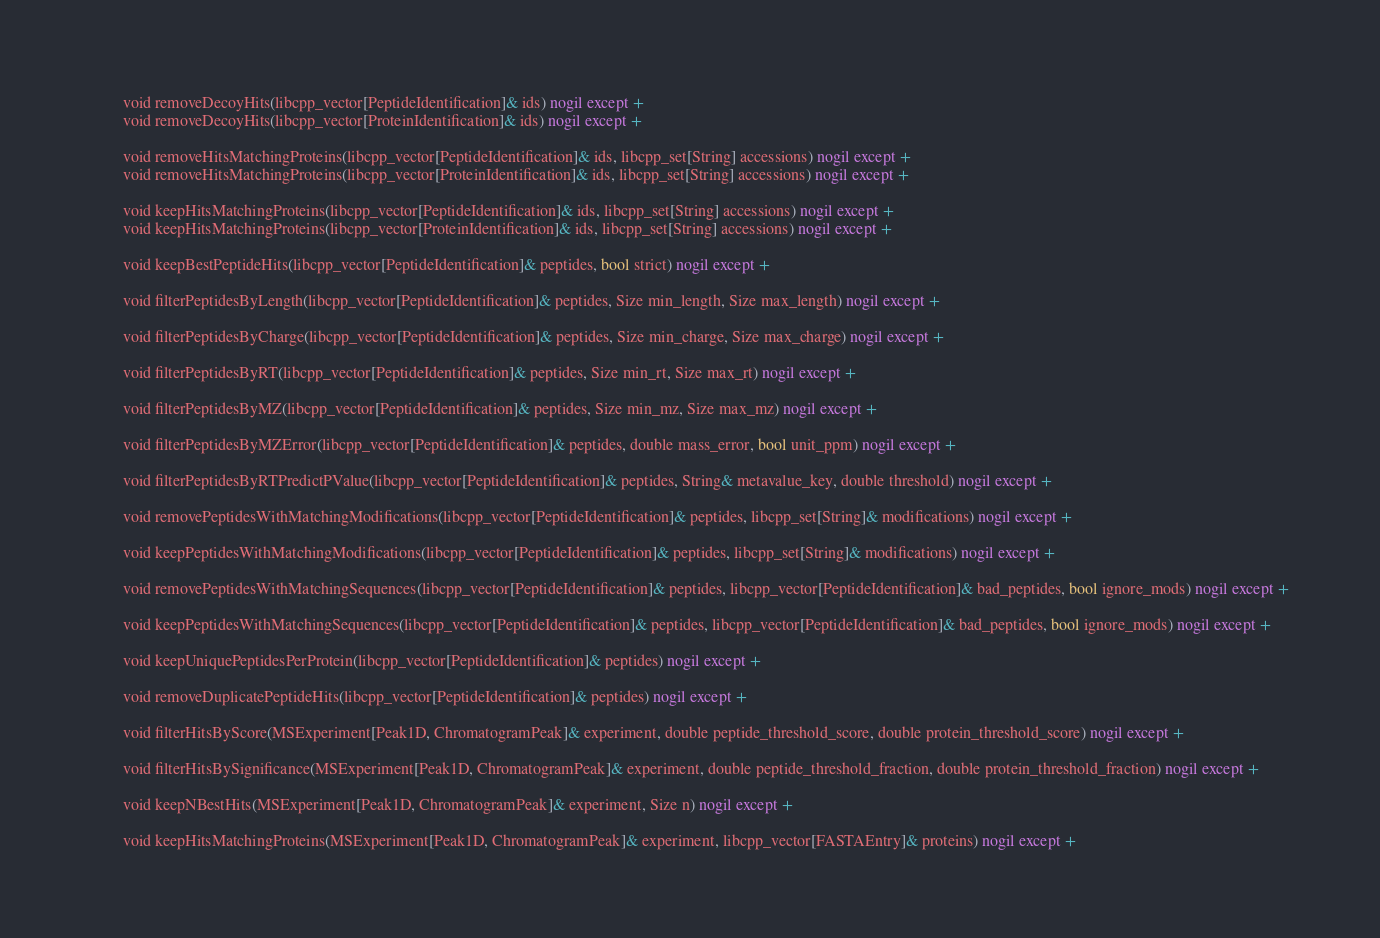<code> <loc_0><loc_0><loc_500><loc_500><_Cython_>        void removeDecoyHits(libcpp_vector[PeptideIdentification]& ids) nogil except +
        void removeDecoyHits(libcpp_vector[ProteinIdentification]& ids) nogil except +

        void removeHitsMatchingProteins(libcpp_vector[PeptideIdentification]& ids, libcpp_set[String] accessions) nogil except +
        void removeHitsMatchingProteins(libcpp_vector[ProteinIdentification]& ids, libcpp_set[String] accessions) nogil except +

        void keepHitsMatchingProteins(libcpp_vector[PeptideIdentification]& ids, libcpp_set[String] accessions) nogil except +
        void keepHitsMatchingProteins(libcpp_vector[ProteinIdentification]& ids, libcpp_set[String] accessions) nogil except +

        void keepBestPeptideHits(libcpp_vector[PeptideIdentification]& peptides, bool strict) nogil except +

        void filterPeptidesByLength(libcpp_vector[PeptideIdentification]& peptides, Size min_length, Size max_length) nogil except +

        void filterPeptidesByCharge(libcpp_vector[PeptideIdentification]& peptides, Size min_charge, Size max_charge) nogil except +

        void filterPeptidesByRT(libcpp_vector[PeptideIdentification]& peptides, Size min_rt, Size max_rt) nogil except +

        void filterPeptidesByMZ(libcpp_vector[PeptideIdentification]& peptides, Size min_mz, Size max_mz) nogil except +

        void filterPeptidesByMZError(libcpp_vector[PeptideIdentification]& peptides, double mass_error, bool unit_ppm) nogil except +

        void filterPeptidesByRTPredictPValue(libcpp_vector[PeptideIdentification]& peptides, String& metavalue_key, double threshold) nogil except +

        void removePeptidesWithMatchingModifications(libcpp_vector[PeptideIdentification]& peptides, libcpp_set[String]& modifications) nogil except +

        void keepPeptidesWithMatchingModifications(libcpp_vector[PeptideIdentification]& peptides, libcpp_set[String]& modifications) nogil except +

        void removePeptidesWithMatchingSequences(libcpp_vector[PeptideIdentification]& peptides, libcpp_vector[PeptideIdentification]& bad_peptides, bool ignore_mods) nogil except +

        void keepPeptidesWithMatchingSequences(libcpp_vector[PeptideIdentification]& peptides, libcpp_vector[PeptideIdentification]& bad_peptides, bool ignore_mods) nogil except +

        void keepUniquePeptidesPerProtein(libcpp_vector[PeptideIdentification]& peptides) nogil except +

        void removeDuplicatePeptideHits(libcpp_vector[PeptideIdentification]& peptides) nogil except +

        void filterHitsByScore(MSExperiment[Peak1D, ChromatogramPeak]& experiment, double peptide_threshold_score, double protein_threshold_score) nogil except +

        void filterHitsBySignificance(MSExperiment[Peak1D, ChromatogramPeak]& experiment, double peptide_threshold_fraction, double protein_threshold_fraction) nogil except +

        void keepNBestHits(MSExperiment[Peak1D, ChromatogramPeak]& experiment, Size n) nogil except +

        void keepHitsMatchingProteins(MSExperiment[Peak1D, ChromatogramPeak]& experiment, libcpp_vector[FASTAEntry]& proteins) nogil except +
</code> 